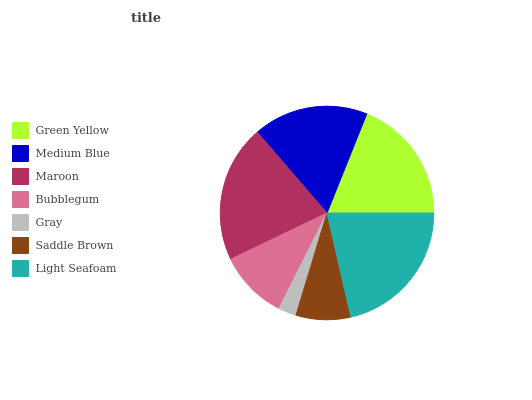Is Gray the minimum?
Answer yes or no. Yes. Is Light Seafoam the maximum?
Answer yes or no. Yes. Is Medium Blue the minimum?
Answer yes or no. No. Is Medium Blue the maximum?
Answer yes or no. No. Is Green Yellow greater than Medium Blue?
Answer yes or no. Yes. Is Medium Blue less than Green Yellow?
Answer yes or no. Yes. Is Medium Blue greater than Green Yellow?
Answer yes or no. No. Is Green Yellow less than Medium Blue?
Answer yes or no. No. Is Medium Blue the high median?
Answer yes or no. Yes. Is Medium Blue the low median?
Answer yes or no. Yes. Is Light Seafoam the high median?
Answer yes or no. No. Is Light Seafoam the low median?
Answer yes or no. No. 